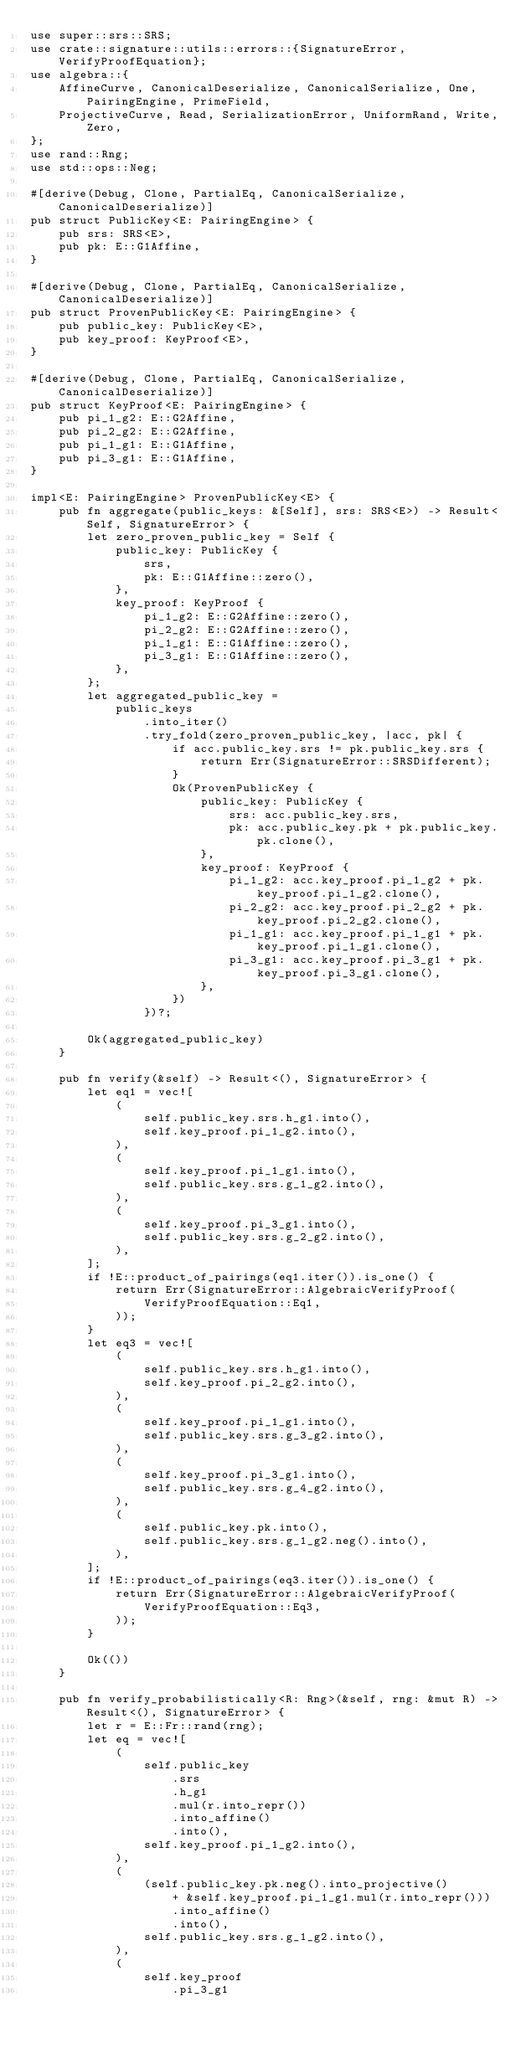<code> <loc_0><loc_0><loc_500><loc_500><_Rust_>use super::srs::SRS;
use crate::signature::utils::errors::{SignatureError, VerifyProofEquation};
use algebra::{
    AffineCurve, CanonicalDeserialize, CanonicalSerialize, One, PairingEngine, PrimeField,
    ProjectiveCurve, Read, SerializationError, UniformRand, Write, Zero,
};
use rand::Rng;
use std::ops::Neg;

#[derive(Debug, Clone, PartialEq, CanonicalSerialize, CanonicalDeserialize)]
pub struct PublicKey<E: PairingEngine> {
    pub srs: SRS<E>,
    pub pk: E::G1Affine,
}

#[derive(Debug, Clone, PartialEq, CanonicalSerialize, CanonicalDeserialize)]
pub struct ProvenPublicKey<E: PairingEngine> {
    pub public_key: PublicKey<E>,
    pub key_proof: KeyProof<E>,
}

#[derive(Debug, Clone, PartialEq, CanonicalSerialize, CanonicalDeserialize)]
pub struct KeyProof<E: PairingEngine> {
    pub pi_1_g2: E::G2Affine,
    pub pi_2_g2: E::G2Affine,
    pub pi_1_g1: E::G1Affine,
    pub pi_3_g1: E::G1Affine,
}

impl<E: PairingEngine> ProvenPublicKey<E> {
    pub fn aggregate(public_keys: &[Self], srs: SRS<E>) -> Result<Self, SignatureError> {
        let zero_proven_public_key = Self {
            public_key: PublicKey {
                srs,
                pk: E::G1Affine::zero(),
            },
            key_proof: KeyProof {
                pi_1_g2: E::G2Affine::zero(),
                pi_2_g2: E::G2Affine::zero(),
                pi_1_g1: E::G1Affine::zero(),
                pi_3_g1: E::G1Affine::zero(),
            },
        };
        let aggregated_public_key =
            public_keys
                .into_iter()
                .try_fold(zero_proven_public_key, |acc, pk| {
                    if acc.public_key.srs != pk.public_key.srs {
                        return Err(SignatureError::SRSDifferent);
                    }
                    Ok(ProvenPublicKey {
                        public_key: PublicKey {
                            srs: acc.public_key.srs,
                            pk: acc.public_key.pk + pk.public_key.pk.clone(),
                        },
                        key_proof: KeyProof {
                            pi_1_g2: acc.key_proof.pi_1_g2 + pk.key_proof.pi_1_g2.clone(),
                            pi_2_g2: acc.key_proof.pi_2_g2 + pk.key_proof.pi_2_g2.clone(),
                            pi_1_g1: acc.key_proof.pi_1_g1 + pk.key_proof.pi_1_g1.clone(),
                            pi_3_g1: acc.key_proof.pi_3_g1 + pk.key_proof.pi_3_g1.clone(),
                        },
                    })
                })?;

        Ok(aggregated_public_key)
    }

    pub fn verify(&self) -> Result<(), SignatureError> {
        let eq1 = vec![
            (
                self.public_key.srs.h_g1.into(),
                self.key_proof.pi_1_g2.into(),
            ),
            (
                self.key_proof.pi_1_g1.into(),
                self.public_key.srs.g_1_g2.into(),
            ),
            (
                self.key_proof.pi_3_g1.into(),
                self.public_key.srs.g_2_g2.into(),
            ),
        ];
        if !E::product_of_pairings(eq1.iter()).is_one() {
            return Err(SignatureError::AlgebraicVerifyProof(
                VerifyProofEquation::Eq1,
            ));
        }
        let eq3 = vec![
            (
                self.public_key.srs.h_g1.into(),
                self.key_proof.pi_2_g2.into(),
            ),
            (
                self.key_proof.pi_1_g1.into(),
                self.public_key.srs.g_3_g2.into(),
            ),
            (
                self.key_proof.pi_3_g1.into(),
                self.public_key.srs.g_4_g2.into(),
            ),
            (
                self.public_key.pk.into(),
                self.public_key.srs.g_1_g2.neg().into(),
            ),
        ];
        if !E::product_of_pairings(eq3.iter()).is_one() {
            return Err(SignatureError::AlgebraicVerifyProof(
                VerifyProofEquation::Eq3,
            ));
        }

        Ok(())
    }

    pub fn verify_probabilistically<R: Rng>(&self, rng: &mut R) -> Result<(), SignatureError> {
        let r = E::Fr::rand(rng);
        let eq = vec![
            (
                self.public_key
                    .srs
                    .h_g1
                    .mul(r.into_repr())
                    .into_affine()
                    .into(),
                self.key_proof.pi_1_g2.into(),
            ),
            (
                (self.public_key.pk.neg().into_projective()
                    + &self.key_proof.pi_1_g1.mul(r.into_repr()))
                    .into_affine()
                    .into(),
                self.public_key.srs.g_1_g2.into(),
            ),
            (
                self.key_proof
                    .pi_3_g1</code> 